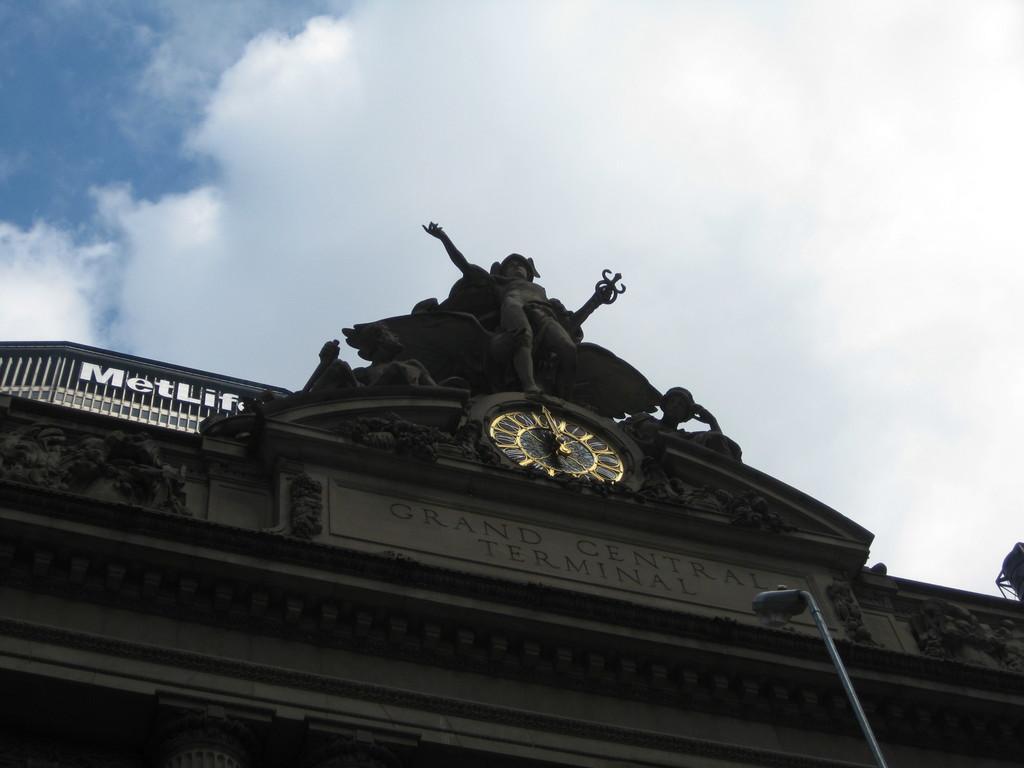How would you summarize this image in a sentence or two? In this image we can see a building, name board, clock, statue, street pole, street light and sky with clouds in the background. 